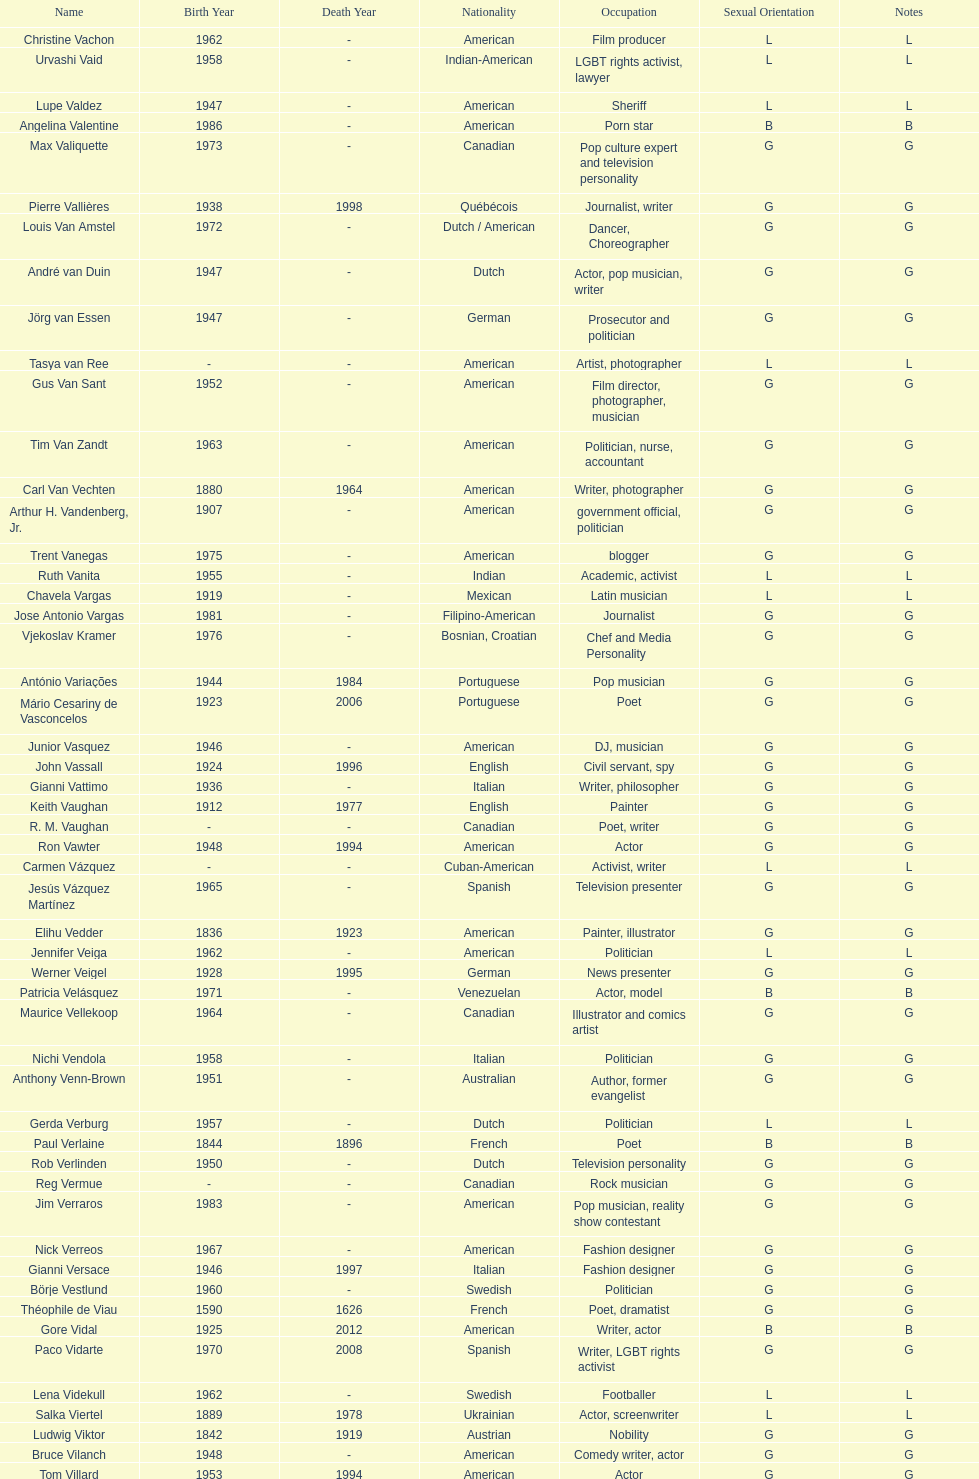Which is the previous name from lupe valdez Urvashi Vaid. 